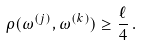<formula> <loc_0><loc_0><loc_500><loc_500>\rho ( \omega ^ { ( j ) } , \omega ^ { ( k ) } ) \geq \frac { \ell } { 4 } \, .</formula> 